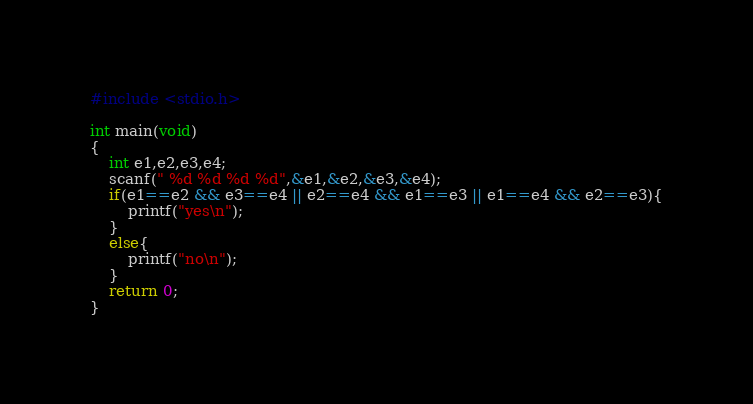Convert code to text. <code><loc_0><loc_0><loc_500><loc_500><_C_>#include <stdio.h>

int main(void)
{
	int e1,e2,e3,e4;
	scanf(" %d %d %d %d",&e1,&e2,&e3,&e4);
	if(e1==e2 && e3==e4 || e2==e4 && e1==e3 || e1==e4 && e2==e3){
		printf("yes\n");
	}
	else{
		printf("no\n");
	}
	return 0;
}
</code> 